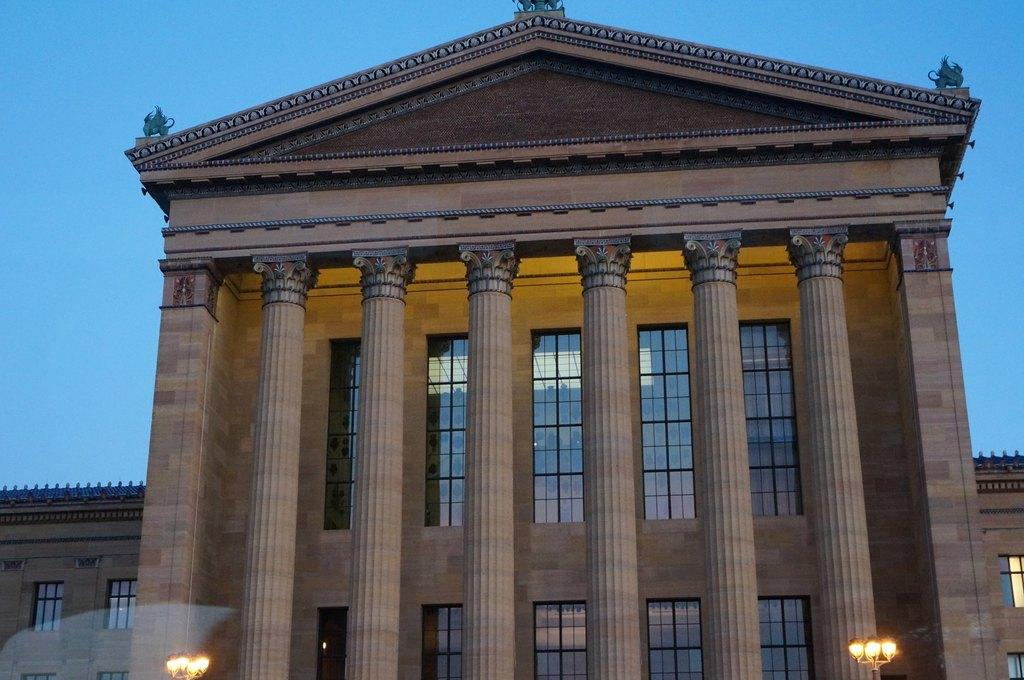What type of structure is present in the image? There is a building in the image. What colors are used for the building? The building is brown and cream in color. What architectural features can be seen on the building? There are windows on the building. Are there any illuminated elements on the building? Yes, there are lights visible on the building. What can be seen in the background of the image? The sky is visible in the background of the image. Where is the mailbox located in the image? There is no mailbox present in the image. Is there a birthday celebration happening in the image? There is no indication of a birthday celebration in the image. 